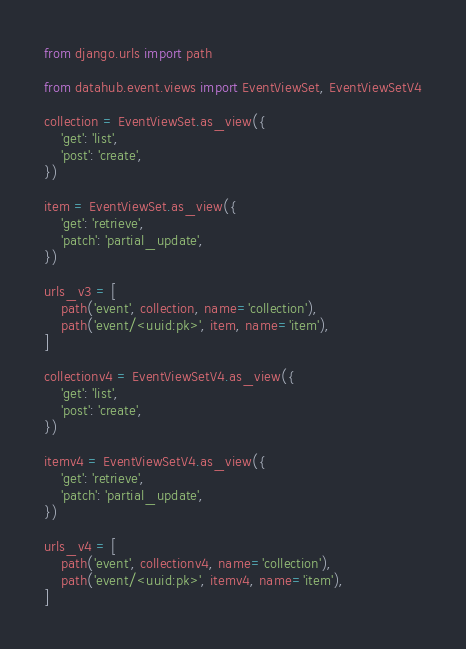<code> <loc_0><loc_0><loc_500><loc_500><_Python_>from django.urls import path

from datahub.event.views import EventViewSet, EventViewSetV4

collection = EventViewSet.as_view({
    'get': 'list',
    'post': 'create',
})

item = EventViewSet.as_view({
    'get': 'retrieve',
    'patch': 'partial_update',
})

urls_v3 = [
    path('event', collection, name='collection'),
    path('event/<uuid:pk>', item, name='item'),
]

collectionv4 = EventViewSetV4.as_view({
    'get': 'list',
    'post': 'create',
})

itemv4 = EventViewSetV4.as_view({
    'get': 'retrieve',
    'patch': 'partial_update',
})

urls_v4 = [
    path('event', collectionv4, name='collection'),
    path('event/<uuid:pk>', itemv4, name='item'),
]
</code> 